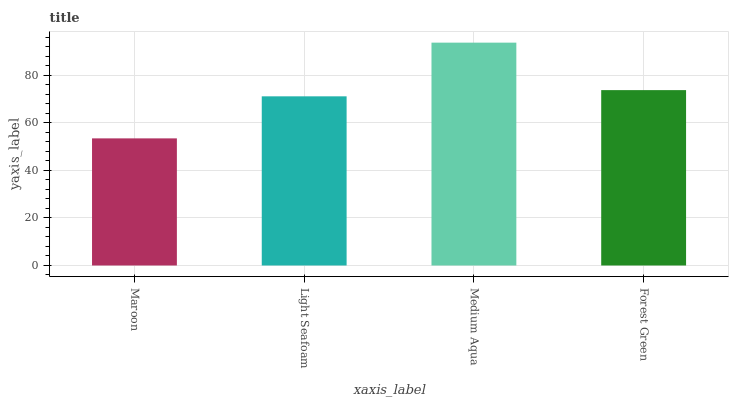Is Maroon the minimum?
Answer yes or no. Yes. Is Medium Aqua the maximum?
Answer yes or no. Yes. Is Light Seafoam the minimum?
Answer yes or no. No. Is Light Seafoam the maximum?
Answer yes or no. No. Is Light Seafoam greater than Maroon?
Answer yes or no. Yes. Is Maroon less than Light Seafoam?
Answer yes or no. Yes. Is Maroon greater than Light Seafoam?
Answer yes or no. No. Is Light Seafoam less than Maroon?
Answer yes or no. No. Is Forest Green the high median?
Answer yes or no. Yes. Is Light Seafoam the low median?
Answer yes or no. Yes. Is Light Seafoam the high median?
Answer yes or no. No. Is Maroon the low median?
Answer yes or no. No. 